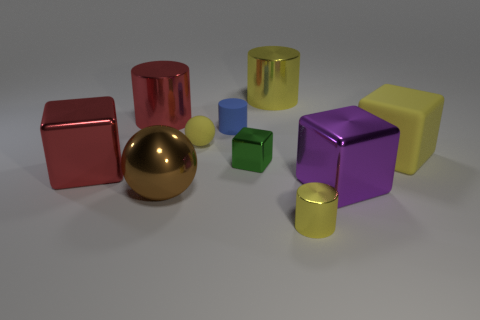How many shiny things are large brown balls or big blocks?
Your response must be concise. 3. There is another cylinder that is the same size as the blue rubber cylinder; what is its material?
Offer a terse response. Metal. What number of other things are made of the same material as the small blue thing?
Your answer should be compact. 2. Is the number of large purple shiny things on the left side of the tiny metallic block less than the number of big cyan metal balls?
Give a very brief answer. No. Does the small green shiny object have the same shape as the purple object?
Make the answer very short. Yes. There is a yellow matte thing that is to the left of the yellow cylinder that is in front of the yellow metal cylinder that is behind the tiny rubber ball; how big is it?
Provide a succinct answer. Small. What material is the big yellow object that is the same shape as the large purple thing?
Provide a short and direct response. Rubber. There is a matte object to the right of the object in front of the big brown metal ball; how big is it?
Provide a succinct answer. Large. The matte block is what color?
Your answer should be compact. Yellow. There is a metal thing that is to the right of the small yellow cylinder; what number of small yellow objects are in front of it?
Provide a short and direct response. 1. 